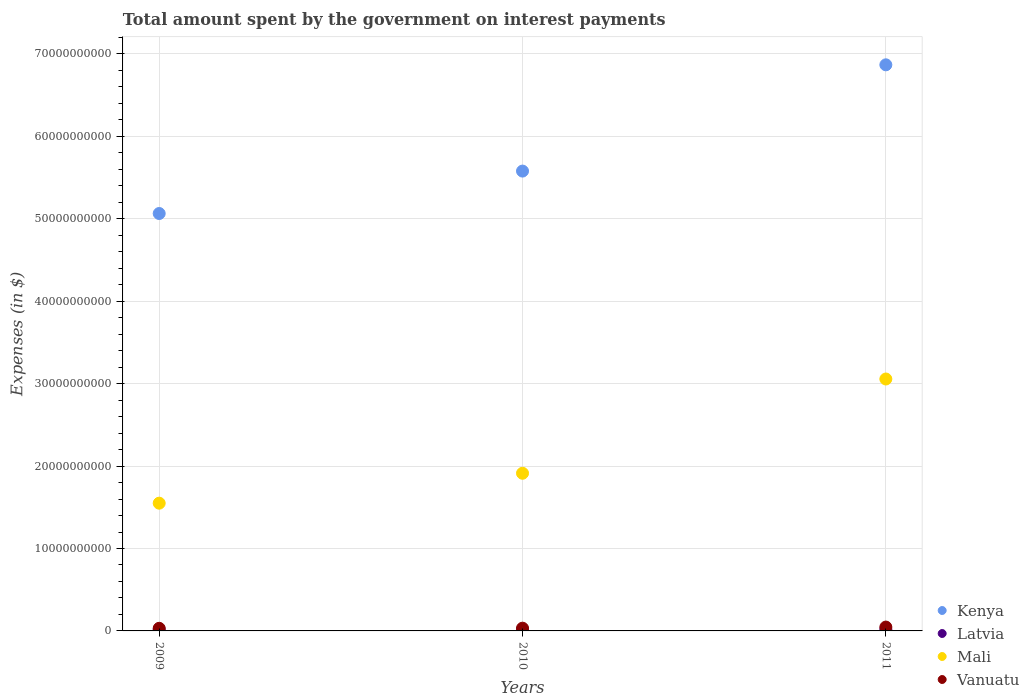How many different coloured dotlines are there?
Give a very brief answer. 4. What is the amount spent on interest payments by the government in Kenya in 2009?
Provide a short and direct response. 5.06e+1. Across all years, what is the maximum amount spent on interest payments by the government in Latvia?
Your answer should be compact. 1.91e+08. Across all years, what is the minimum amount spent on interest payments by the government in Vanuatu?
Your answer should be compact. 3.18e+08. What is the total amount spent on interest payments by the government in Vanuatu in the graph?
Offer a very short reply. 1.12e+09. What is the difference between the amount spent on interest payments by the government in Vanuatu in 2009 and that in 2011?
Make the answer very short. -1.50e+08. What is the difference between the amount spent on interest payments by the government in Mali in 2011 and the amount spent on interest payments by the government in Vanuatu in 2010?
Your response must be concise. 3.02e+1. What is the average amount spent on interest payments by the government in Latvia per year?
Ensure brevity in your answer.  1.68e+08. In the year 2010, what is the difference between the amount spent on interest payments by the government in Mali and amount spent on interest payments by the government in Kenya?
Make the answer very short. -3.67e+1. In how many years, is the amount spent on interest payments by the government in Vanuatu greater than 18000000000 $?
Give a very brief answer. 0. What is the ratio of the amount spent on interest payments by the government in Mali in 2009 to that in 2010?
Your answer should be compact. 0.81. Is the difference between the amount spent on interest payments by the government in Mali in 2009 and 2010 greater than the difference between the amount spent on interest payments by the government in Kenya in 2009 and 2010?
Ensure brevity in your answer.  Yes. What is the difference between the highest and the second highest amount spent on interest payments by the government in Latvia?
Provide a short and direct response. 2.07e+07. What is the difference between the highest and the lowest amount spent on interest payments by the government in Vanuatu?
Keep it short and to the point. 1.50e+08. In how many years, is the amount spent on interest payments by the government in Kenya greater than the average amount spent on interest payments by the government in Kenya taken over all years?
Provide a short and direct response. 1. Is the sum of the amount spent on interest payments by the government in Latvia in 2010 and 2011 greater than the maximum amount spent on interest payments by the government in Vanuatu across all years?
Ensure brevity in your answer.  No. Is it the case that in every year, the sum of the amount spent on interest payments by the government in Kenya and amount spent on interest payments by the government in Vanuatu  is greater than the amount spent on interest payments by the government in Mali?
Give a very brief answer. Yes. Does the amount spent on interest payments by the government in Latvia monotonically increase over the years?
Your answer should be very brief. Yes. How many dotlines are there?
Your answer should be compact. 4. How many years are there in the graph?
Your answer should be very brief. 3. What is the difference between two consecutive major ticks on the Y-axis?
Offer a very short reply. 1.00e+1. Does the graph contain any zero values?
Your answer should be compact. No. Where does the legend appear in the graph?
Your answer should be compact. Bottom right. How are the legend labels stacked?
Ensure brevity in your answer.  Vertical. What is the title of the graph?
Your answer should be compact. Total amount spent by the government on interest payments. What is the label or title of the Y-axis?
Offer a terse response. Expenses (in $). What is the Expenses (in $) of Kenya in 2009?
Your answer should be very brief. 5.06e+1. What is the Expenses (in $) of Latvia in 2009?
Ensure brevity in your answer.  1.44e+08. What is the Expenses (in $) of Mali in 2009?
Offer a terse response. 1.55e+1. What is the Expenses (in $) of Vanuatu in 2009?
Offer a very short reply. 3.18e+08. What is the Expenses (in $) of Kenya in 2010?
Provide a succinct answer. 5.58e+1. What is the Expenses (in $) of Latvia in 2010?
Give a very brief answer. 1.70e+08. What is the Expenses (in $) in Mali in 2010?
Offer a very short reply. 1.91e+1. What is the Expenses (in $) in Vanuatu in 2010?
Keep it short and to the point. 3.34e+08. What is the Expenses (in $) of Kenya in 2011?
Your answer should be compact. 6.87e+1. What is the Expenses (in $) of Latvia in 2011?
Give a very brief answer. 1.91e+08. What is the Expenses (in $) of Mali in 2011?
Make the answer very short. 3.06e+1. What is the Expenses (in $) of Vanuatu in 2011?
Your answer should be very brief. 4.68e+08. Across all years, what is the maximum Expenses (in $) of Kenya?
Your answer should be very brief. 6.87e+1. Across all years, what is the maximum Expenses (in $) in Latvia?
Provide a succinct answer. 1.91e+08. Across all years, what is the maximum Expenses (in $) in Mali?
Keep it short and to the point. 3.06e+1. Across all years, what is the maximum Expenses (in $) of Vanuatu?
Make the answer very short. 4.68e+08. Across all years, what is the minimum Expenses (in $) in Kenya?
Provide a succinct answer. 5.06e+1. Across all years, what is the minimum Expenses (in $) of Latvia?
Ensure brevity in your answer.  1.44e+08. Across all years, what is the minimum Expenses (in $) in Mali?
Provide a succinct answer. 1.55e+1. Across all years, what is the minimum Expenses (in $) in Vanuatu?
Keep it short and to the point. 3.18e+08. What is the total Expenses (in $) in Kenya in the graph?
Ensure brevity in your answer.  1.75e+11. What is the total Expenses (in $) of Latvia in the graph?
Provide a succinct answer. 5.05e+08. What is the total Expenses (in $) of Mali in the graph?
Give a very brief answer. 6.52e+1. What is the total Expenses (in $) of Vanuatu in the graph?
Offer a terse response. 1.12e+09. What is the difference between the Expenses (in $) in Kenya in 2009 and that in 2010?
Your response must be concise. -5.15e+09. What is the difference between the Expenses (in $) of Latvia in 2009 and that in 2010?
Offer a very short reply. -2.62e+07. What is the difference between the Expenses (in $) of Mali in 2009 and that in 2010?
Ensure brevity in your answer.  -3.63e+09. What is the difference between the Expenses (in $) in Vanuatu in 2009 and that in 2010?
Your answer should be compact. -1.57e+07. What is the difference between the Expenses (in $) of Kenya in 2009 and that in 2011?
Your answer should be compact. -1.80e+1. What is the difference between the Expenses (in $) in Latvia in 2009 and that in 2011?
Make the answer very short. -4.69e+07. What is the difference between the Expenses (in $) in Mali in 2009 and that in 2011?
Provide a short and direct response. -1.51e+1. What is the difference between the Expenses (in $) of Vanuatu in 2009 and that in 2011?
Keep it short and to the point. -1.50e+08. What is the difference between the Expenses (in $) of Kenya in 2010 and that in 2011?
Keep it short and to the point. -1.29e+1. What is the difference between the Expenses (in $) in Latvia in 2010 and that in 2011?
Your response must be concise. -2.07e+07. What is the difference between the Expenses (in $) in Mali in 2010 and that in 2011?
Your answer should be very brief. -1.14e+1. What is the difference between the Expenses (in $) of Vanuatu in 2010 and that in 2011?
Your answer should be very brief. -1.34e+08. What is the difference between the Expenses (in $) of Kenya in 2009 and the Expenses (in $) of Latvia in 2010?
Your response must be concise. 5.05e+1. What is the difference between the Expenses (in $) in Kenya in 2009 and the Expenses (in $) in Mali in 2010?
Your answer should be compact. 3.15e+1. What is the difference between the Expenses (in $) in Kenya in 2009 and the Expenses (in $) in Vanuatu in 2010?
Make the answer very short. 5.03e+1. What is the difference between the Expenses (in $) in Latvia in 2009 and the Expenses (in $) in Mali in 2010?
Ensure brevity in your answer.  -1.90e+1. What is the difference between the Expenses (in $) of Latvia in 2009 and the Expenses (in $) of Vanuatu in 2010?
Your answer should be compact. -1.89e+08. What is the difference between the Expenses (in $) of Mali in 2009 and the Expenses (in $) of Vanuatu in 2010?
Give a very brief answer. 1.52e+1. What is the difference between the Expenses (in $) in Kenya in 2009 and the Expenses (in $) in Latvia in 2011?
Your answer should be compact. 5.04e+1. What is the difference between the Expenses (in $) in Kenya in 2009 and the Expenses (in $) in Mali in 2011?
Keep it short and to the point. 2.01e+1. What is the difference between the Expenses (in $) of Kenya in 2009 and the Expenses (in $) of Vanuatu in 2011?
Give a very brief answer. 5.02e+1. What is the difference between the Expenses (in $) of Latvia in 2009 and the Expenses (in $) of Mali in 2011?
Your response must be concise. -3.04e+1. What is the difference between the Expenses (in $) of Latvia in 2009 and the Expenses (in $) of Vanuatu in 2011?
Make the answer very short. -3.23e+08. What is the difference between the Expenses (in $) in Mali in 2009 and the Expenses (in $) in Vanuatu in 2011?
Make the answer very short. 1.50e+1. What is the difference between the Expenses (in $) in Kenya in 2010 and the Expenses (in $) in Latvia in 2011?
Provide a succinct answer. 5.56e+1. What is the difference between the Expenses (in $) of Kenya in 2010 and the Expenses (in $) of Mali in 2011?
Ensure brevity in your answer.  2.52e+1. What is the difference between the Expenses (in $) of Kenya in 2010 and the Expenses (in $) of Vanuatu in 2011?
Provide a short and direct response. 5.53e+1. What is the difference between the Expenses (in $) of Latvia in 2010 and the Expenses (in $) of Mali in 2011?
Your response must be concise. -3.04e+1. What is the difference between the Expenses (in $) of Latvia in 2010 and the Expenses (in $) of Vanuatu in 2011?
Your answer should be compact. -2.97e+08. What is the difference between the Expenses (in $) of Mali in 2010 and the Expenses (in $) of Vanuatu in 2011?
Keep it short and to the point. 1.87e+1. What is the average Expenses (in $) in Kenya per year?
Offer a terse response. 5.84e+1. What is the average Expenses (in $) of Latvia per year?
Provide a short and direct response. 1.68e+08. What is the average Expenses (in $) in Mali per year?
Make the answer very short. 2.17e+1. What is the average Expenses (in $) of Vanuatu per year?
Keep it short and to the point. 3.73e+08. In the year 2009, what is the difference between the Expenses (in $) of Kenya and Expenses (in $) of Latvia?
Give a very brief answer. 5.05e+1. In the year 2009, what is the difference between the Expenses (in $) in Kenya and Expenses (in $) in Mali?
Make the answer very short. 3.51e+1. In the year 2009, what is the difference between the Expenses (in $) in Kenya and Expenses (in $) in Vanuatu?
Ensure brevity in your answer.  5.03e+1. In the year 2009, what is the difference between the Expenses (in $) in Latvia and Expenses (in $) in Mali?
Your response must be concise. -1.54e+1. In the year 2009, what is the difference between the Expenses (in $) in Latvia and Expenses (in $) in Vanuatu?
Your answer should be very brief. -1.74e+08. In the year 2009, what is the difference between the Expenses (in $) in Mali and Expenses (in $) in Vanuatu?
Make the answer very short. 1.52e+1. In the year 2010, what is the difference between the Expenses (in $) of Kenya and Expenses (in $) of Latvia?
Give a very brief answer. 5.56e+1. In the year 2010, what is the difference between the Expenses (in $) in Kenya and Expenses (in $) in Mali?
Your answer should be very brief. 3.67e+1. In the year 2010, what is the difference between the Expenses (in $) in Kenya and Expenses (in $) in Vanuatu?
Ensure brevity in your answer.  5.55e+1. In the year 2010, what is the difference between the Expenses (in $) in Latvia and Expenses (in $) in Mali?
Provide a short and direct response. -1.90e+1. In the year 2010, what is the difference between the Expenses (in $) of Latvia and Expenses (in $) of Vanuatu?
Your response must be concise. -1.63e+08. In the year 2010, what is the difference between the Expenses (in $) in Mali and Expenses (in $) in Vanuatu?
Provide a short and direct response. 1.88e+1. In the year 2011, what is the difference between the Expenses (in $) in Kenya and Expenses (in $) in Latvia?
Offer a very short reply. 6.85e+1. In the year 2011, what is the difference between the Expenses (in $) in Kenya and Expenses (in $) in Mali?
Offer a very short reply. 3.81e+1. In the year 2011, what is the difference between the Expenses (in $) in Kenya and Expenses (in $) in Vanuatu?
Provide a succinct answer. 6.82e+1. In the year 2011, what is the difference between the Expenses (in $) of Latvia and Expenses (in $) of Mali?
Your answer should be compact. -3.04e+1. In the year 2011, what is the difference between the Expenses (in $) in Latvia and Expenses (in $) in Vanuatu?
Offer a terse response. -2.77e+08. In the year 2011, what is the difference between the Expenses (in $) in Mali and Expenses (in $) in Vanuatu?
Offer a terse response. 3.01e+1. What is the ratio of the Expenses (in $) in Kenya in 2009 to that in 2010?
Give a very brief answer. 0.91. What is the ratio of the Expenses (in $) of Latvia in 2009 to that in 2010?
Keep it short and to the point. 0.85. What is the ratio of the Expenses (in $) in Mali in 2009 to that in 2010?
Make the answer very short. 0.81. What is the ratio of the Expenses (in $) of Vanuatu in 2009 to that in 2010?
Provide a succinct answer. 0.95. What is the ratio of the Expenses (in $) in Kenya in 2009 to that in 2011?
Give a very brief answer. 0.74. What is the ratio of the Expenses (in $) in Latvia in 2009 to that in 2011?
Keep it short and to the point. 0.75. What is the ratio of the Expenses (in $) in Mali in 2009 to that in 2011?
Your response must be concise. 0.51. What is the ratio of the Expenses (in $) in Vanuatu in 2009 to that in 2011?
Your answer should be very brief. 0.68. What is the ratio of the Expenses (in $) of Kenya in 2010 to that in 2011?
Your answer should be very brief. 0.81. What is the ratio of the Expenses (in $) of Latvia in 2010 to that in 2011?
Your response must be concise. 0.89. What is the ratio of the Expenses (in $) in Mali in 2010 to that in 2011?
Make the answer very short. 0.63. What is the ratio of the Expenses (in $) in Vanuatu in 2010 to that in 2011?
Make the answer very short. 0.71. What is the difference between the highest and the second highest Expenses (in $) of Kenya?
Ensure brevity in your answer.  1.29e+1. What is the difference between the highest and the second highest Expenses (in $) in Latvia?
Ensure brevity in your answer.  2.07e+07. What is the difference between the highest and the second highest Expenses (in $) in Mali?
Your answer should be compact. 1.14e+1. What is the difference between the highest and the second highest Expenses (in $) in Vanuatu?
Offer a terse response. 1.34e+08. What is the difference between the highest and the lowest Expenses (in $) of Kenya?
Your answer should be compact. 1.80e+1. What is the difference between the highest and the lowest Expenses (in $) in Latvia?
Make the answer very short. 4.69e+07. What is the difference between the highest and the lowest Expenses (in $) in Mali?
Provide a short and direct response. 1.51e+1. What is the difference between the highest and the lowest Expenses (in $) of Vanuatu?
Make the answer very short. 1.50e+08. 